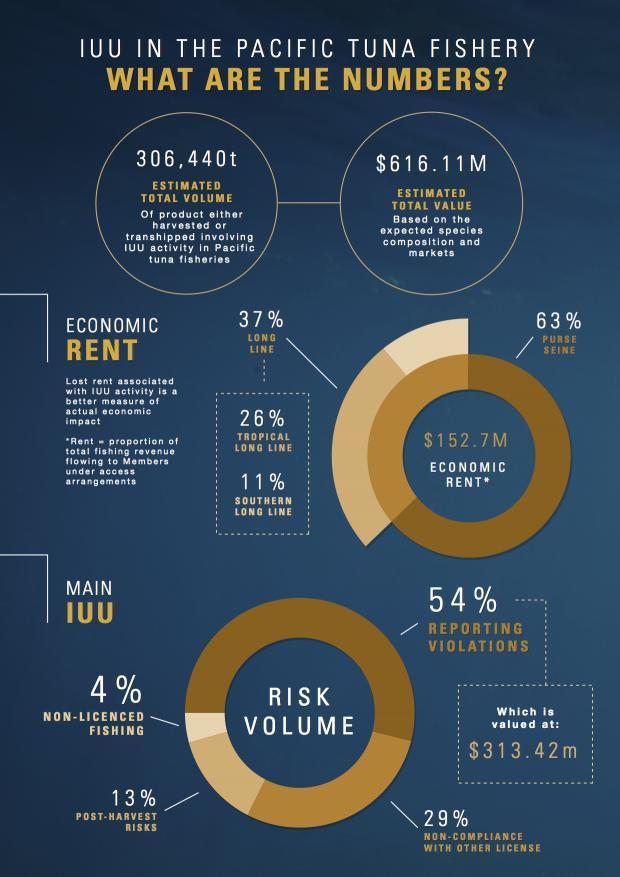Which are the categories of long line economic rent?
Answer the question with a short phrase. Tropical long line, Southern long line Which are two types of economic rents? Long Line, Purse Siene Which has the second lowest risk volume? Post-Harvest Risks Which category of long line contributes to a higher percentage of long line economic rent ? Tropical Long line How much more is the risk percentage of reporting violations in comparison to non-licenced fishing? 50% 